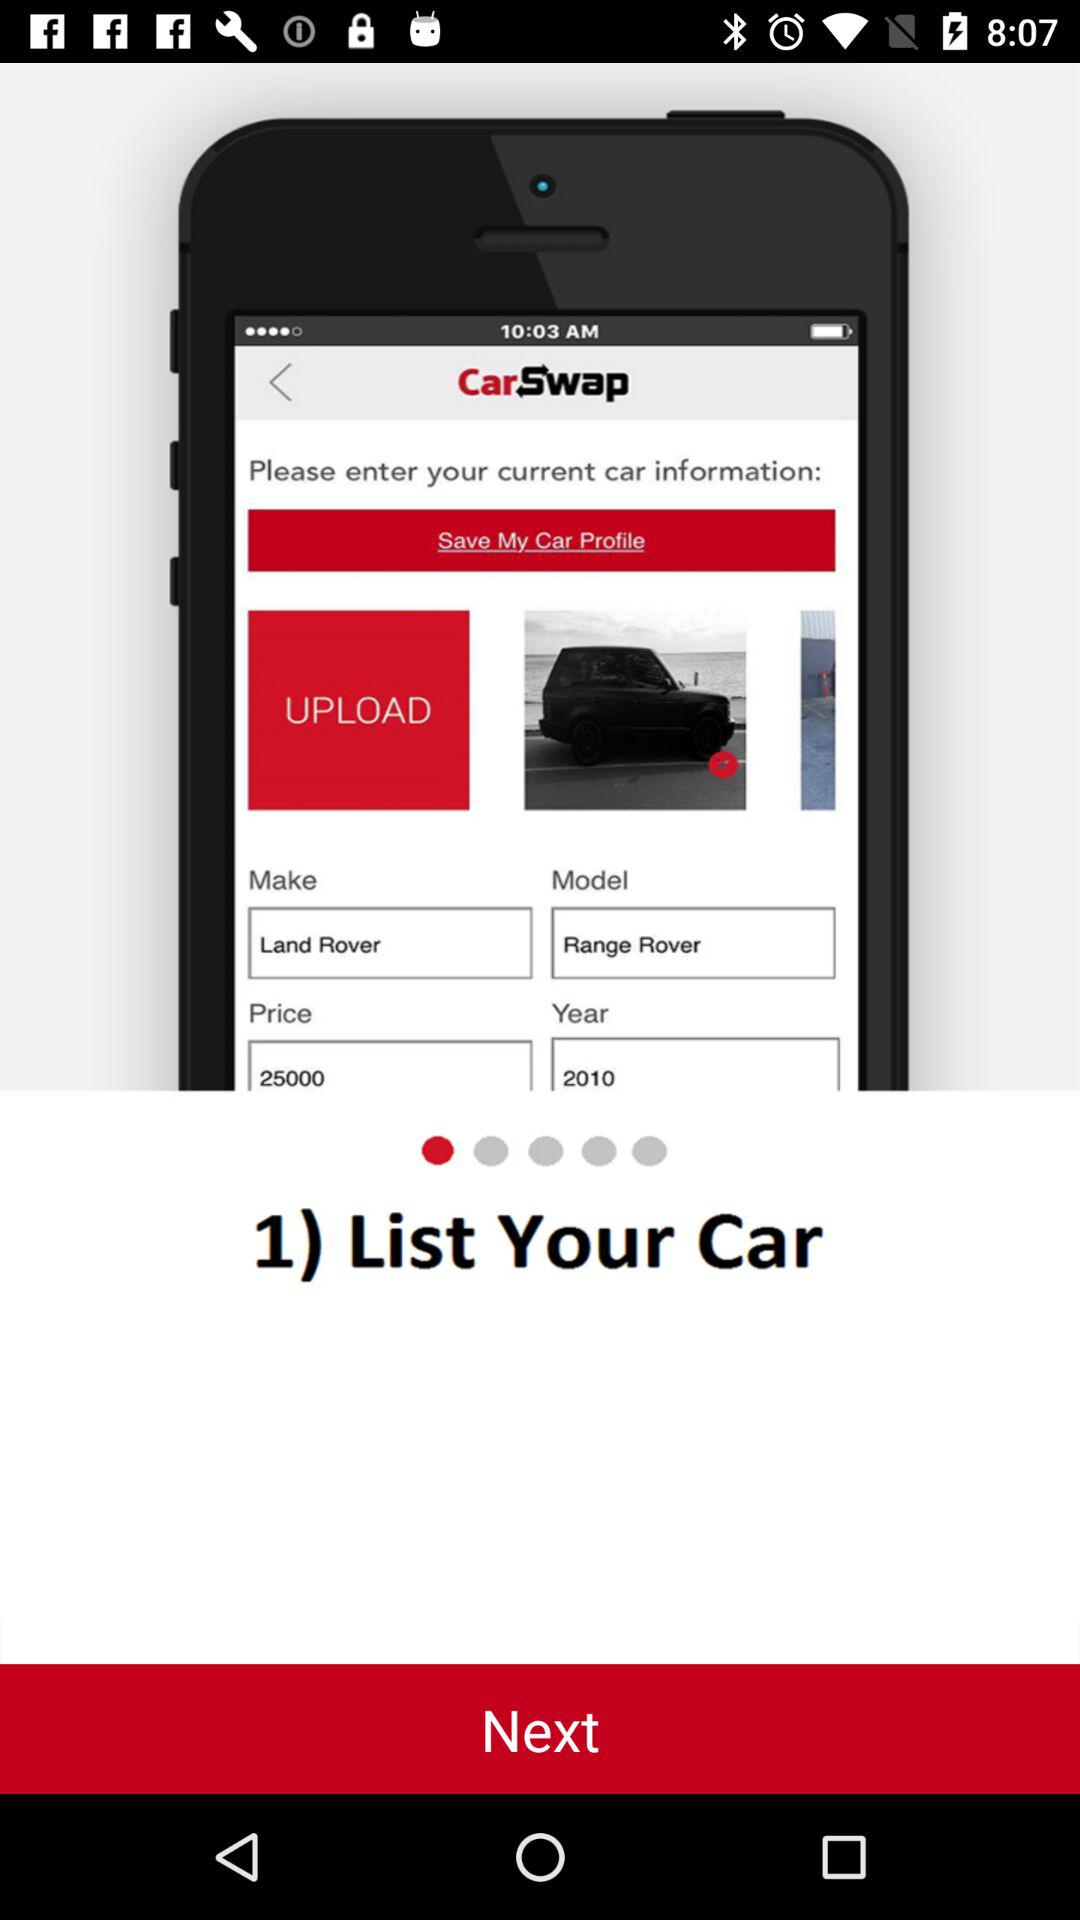What is the price of Range Rover? The price of Range Rover is 25000. 